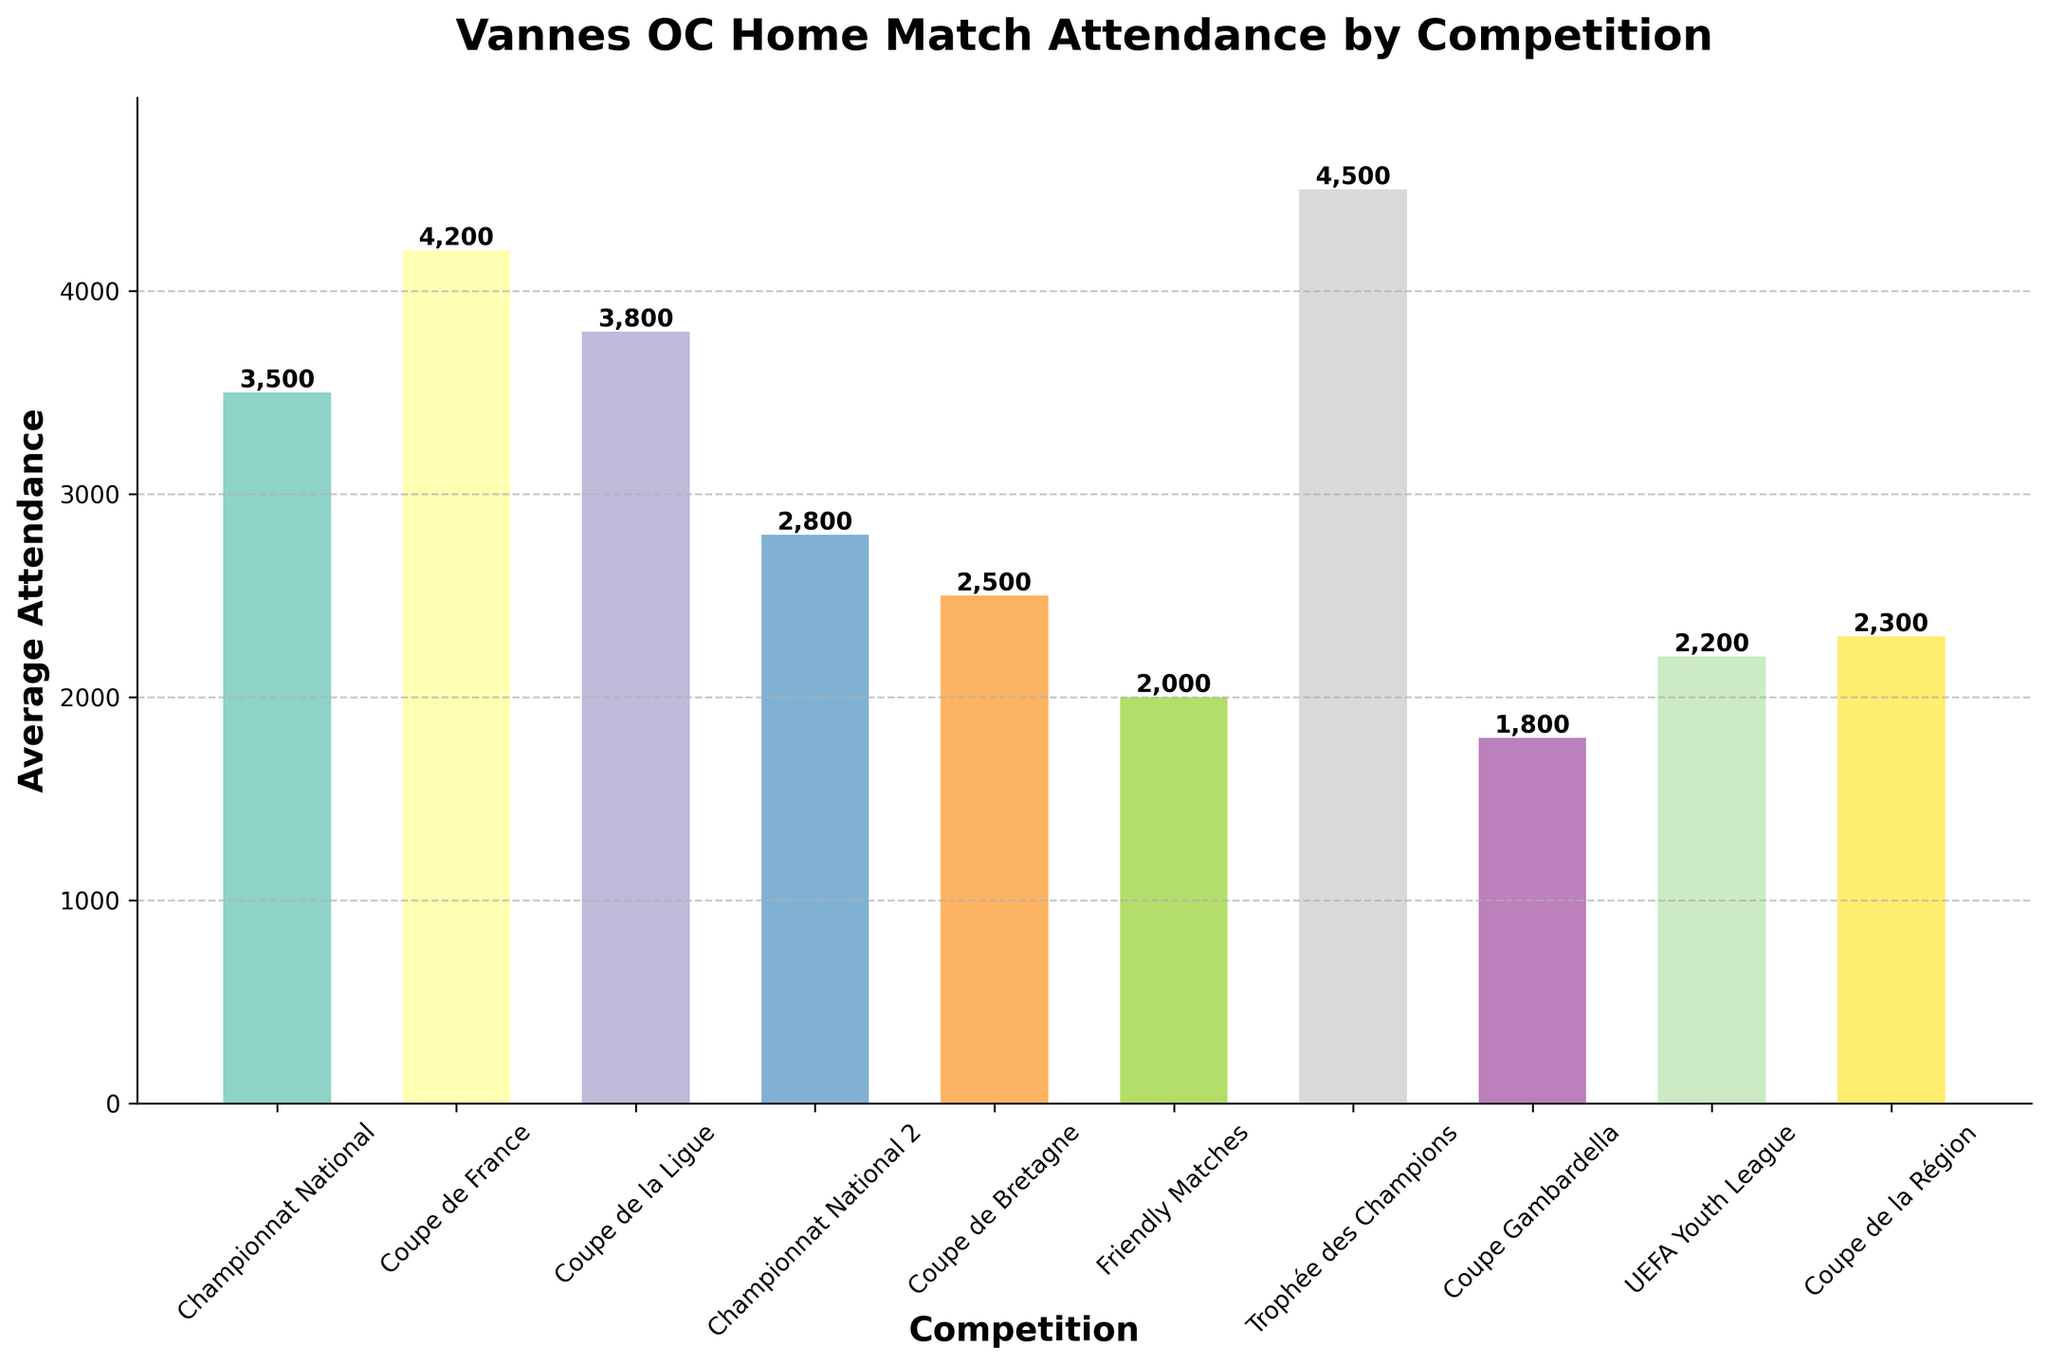What's the competition with the highest average attendance? The "Trophée des Champions" bar is the tallest among all the bars in the chart, indicating the highest average attendance.
Answer: Trophée des Champions Which competition has the lowest average attendance? The "Coupe Gambardella" bar is the shortest among all the bars in the chart, indicating the lowest average attendance.
Answer: Coupe Gambardella What is the range of average attendances? To find the range, subtract the lowest attendance (Coupe Gambardella: 1800) from the highest attendance (Trophée des Champions: 4500). The range is 4500 - 1800 = 2700.
Answer: 2700 Which competition has more average attendance: Championnat National or Championnat National 2? The bar for Championnat National is taller than the bar for Championnat National 2, indicating a higher average attendance for Championnat National.
Answer: Championnat National What is the difference in attendance between Coupe de la Ligue and Coupe Gambardella? Subtract the average attendance of Coupe Gambardella (1800) from Coupe de la Ligue (3800). The difference is 3800 - 1800 = 2000.
Answer: 2000 How many competitions have an average attendance over 3000? The bars for "Championnat National", "Coupe de France", "Coupe de la Ligue", and "Trophée des Champions" exceed the 3000 mark. Thus, there are 4 competitions.
Answer: 4 Which two competitions have the closest average attendances? The bars for "UEFA Youth League" (2200) and "Coupe de la Région" (2300) are closest in height, with a difference of only 100.
Answer: UEFA Youth League and Coupe de la Région What is the combined average attendance for friendly matches and Coupe de Bretagne? Add the average attendances of friendly matches (2000) and Coupe de Bretagne (2500). The combined attendance is 2000 + 2500 = 4500.
Answer: 4500 How much higher is the average attendance of the Trophée des Champions compared to friendly matches? Subtract the average attendance of friendly matches (2000) from the Trophée des Champions (4500). The difference is 4500 - 2000 = 2500.
Answer: 2500 Which three competitions have the highest average attendances? The bars for "Trophée des Champions", "Coupe de France", and "Coupe de la Ligue" are the three tallest in the chart, indicating the highest average attendances.
Answer: Trophée des Champions, Coupe de France, Coupe de la Ligue 